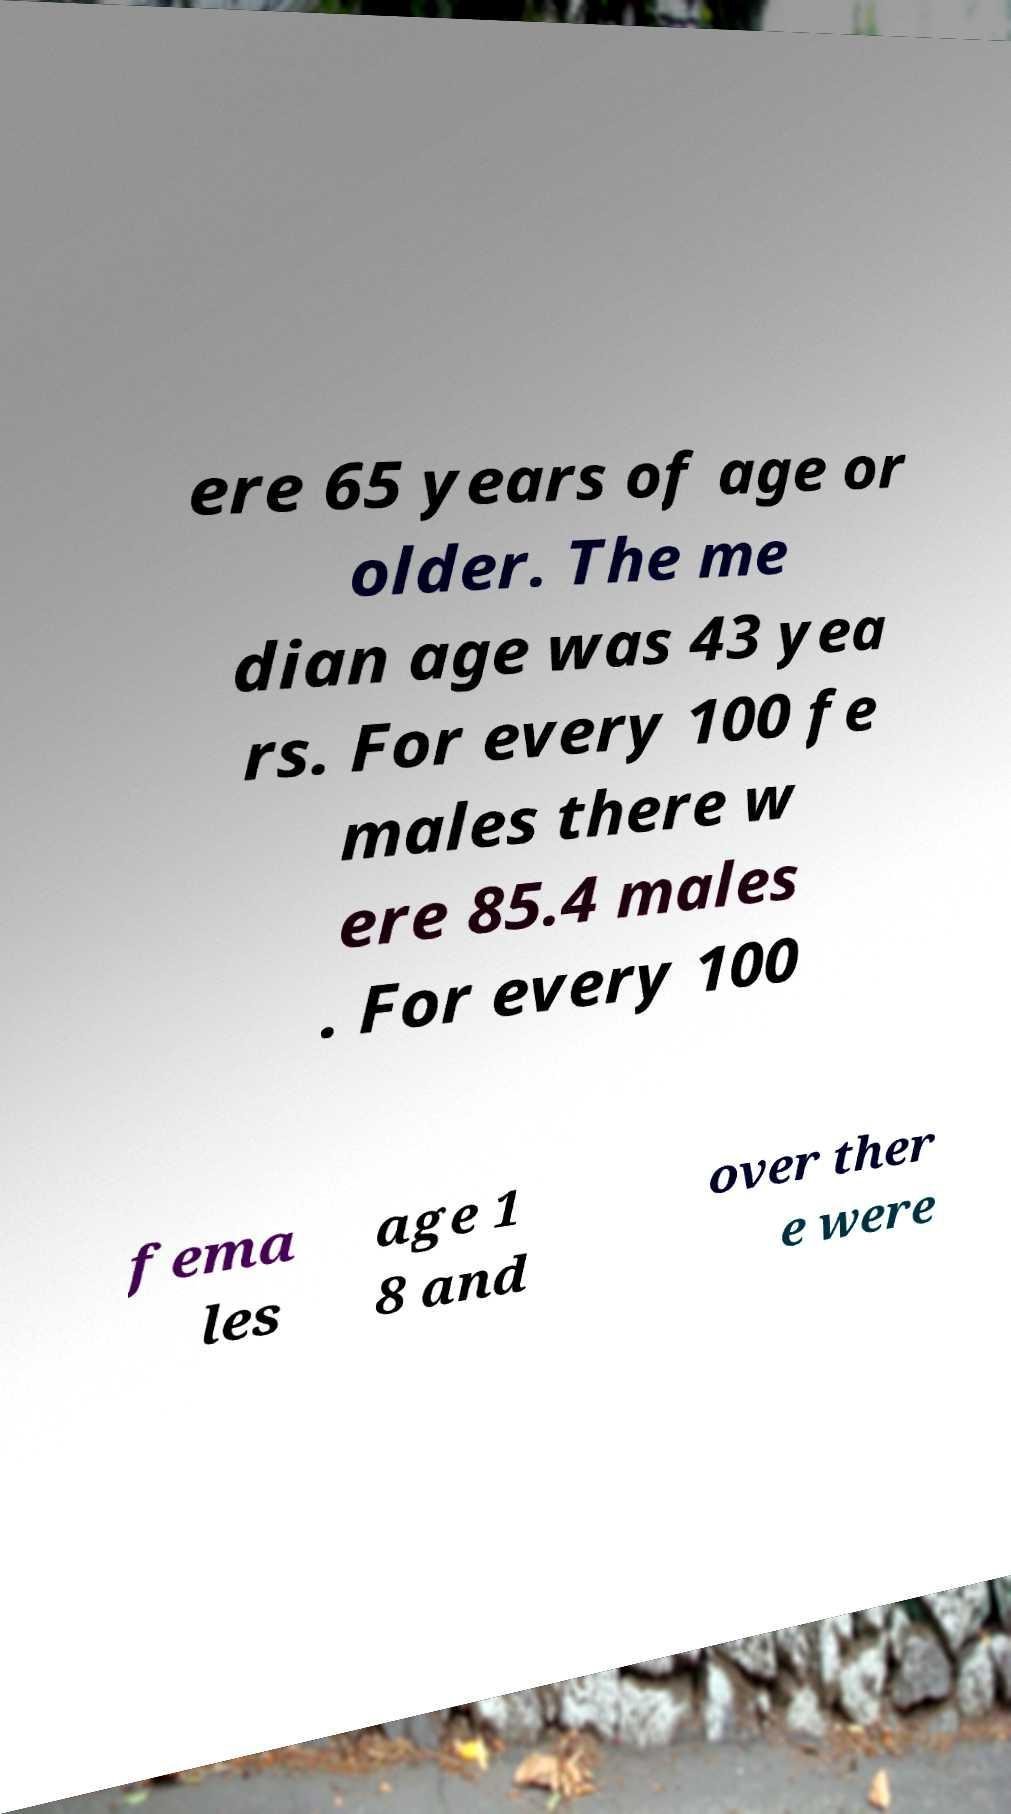What messages or text are displayed in this image? I need them in a readable, typed format. ere 65 years of age or older. The me dian age was 43 yea rs. For every 100 fe males there w ere 85.4 males . For every 100 fema les age 1 8 and over ther e were 